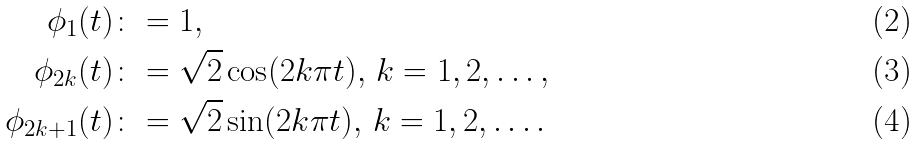<formula> <loc_0><loc_0><loc_500><loc_500>\phi _ { 1 } ( t ) & \colon = 1 , \\ \phi _ { 2 k } ( t ) & \colon = \sqrt { 2 } \cos ( 2 k \pi t ) , \, k = 1 , 2 , \dots , \\ \phi _ { 2 k + 1 } ( t ) & \colon = \sqrt { 2 } \sin ( 2 k \pi t ) , \, k = 1 , 2 , \dots .</formula> 